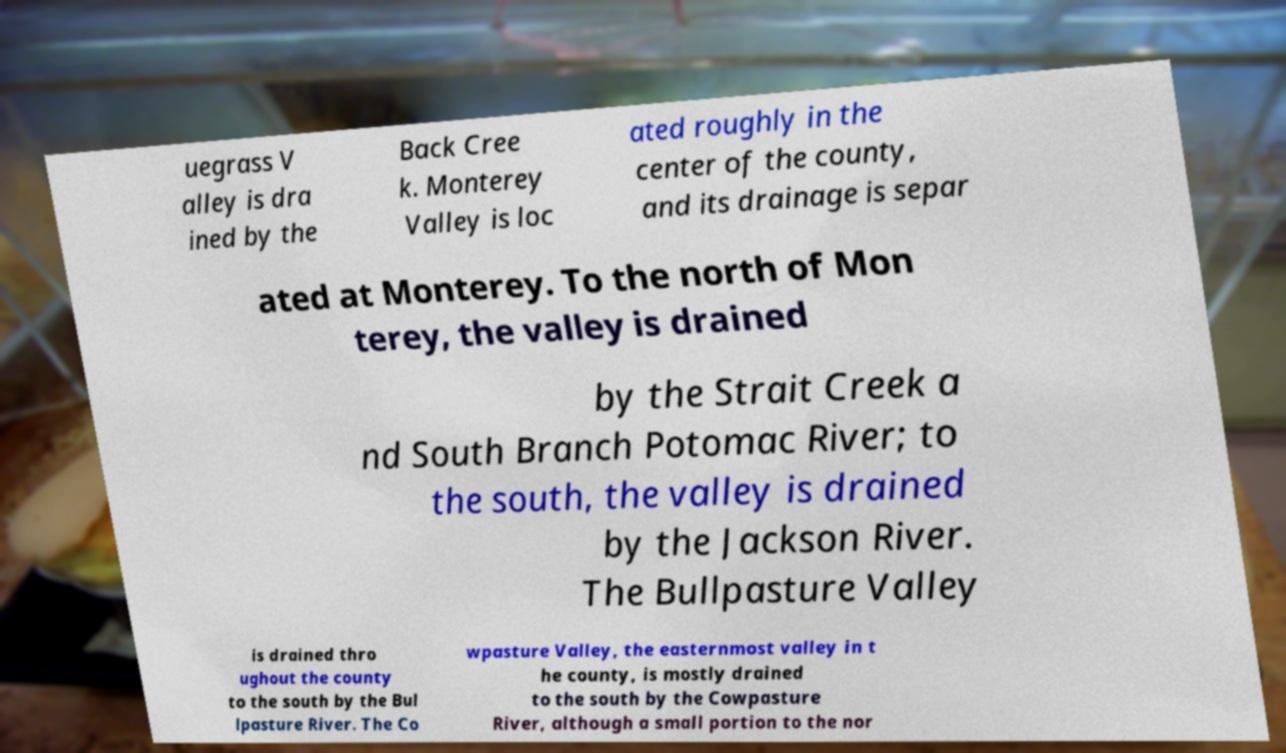For documentation purposes, I need the text within this image transcribed. Could you provide that? uegrass V alley is dra ined by the Back Cree k. Monterey Valley is loc ated roughly in the center of the county, and its drainage is separ ated at Monterey. To the north of Mon terey, the valley is drained by the Strait Creek a nd South Branch Potomac River; to the south, the valley is drained by the Jackson River. The Bullpasture Valley is drained thro ughout the county to the south by the Bul lpasture River. The Co wpasture Valley, the easternmost valley in t he county, is mostly drained to the south by the Cowpasture River, although a small portion to the nor 